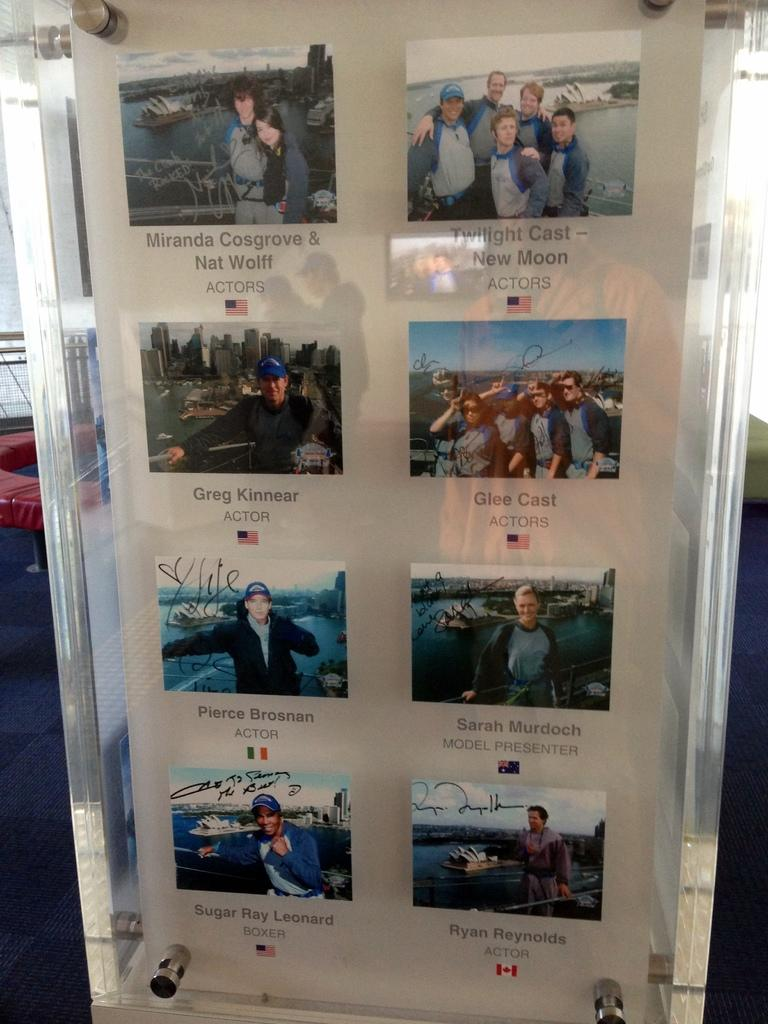Provide a one-sentence caption for the provided image. Pierce Brosnan is pictured over a flag of Ireland. 